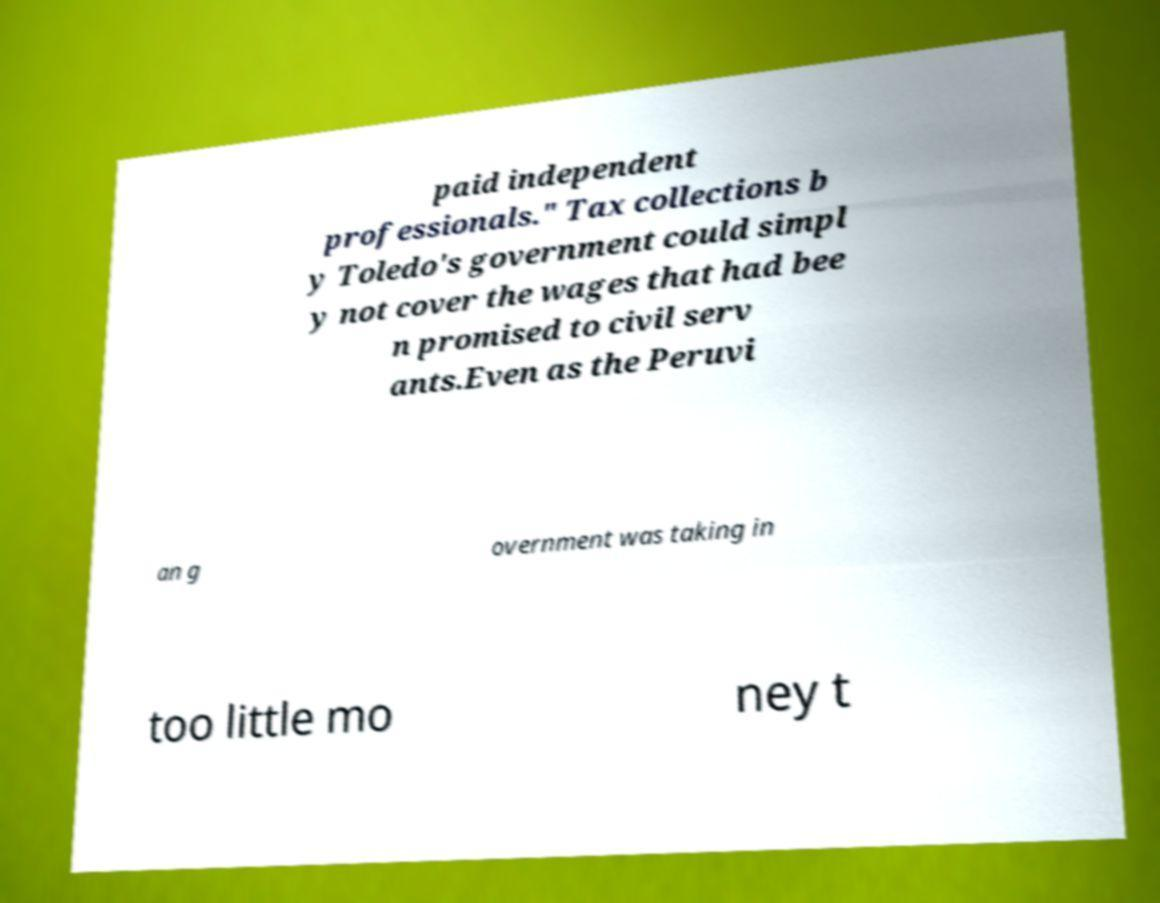There's text embedded in this image that I need extracted. Can you transcribe it verbatim? paid independent professionals." Tax collections b y Toledo's government could simpl y not cover the wages that had bee n promised to civil serv ants.Even as the Peruvi an g overnment was taking in too little mo ney t 